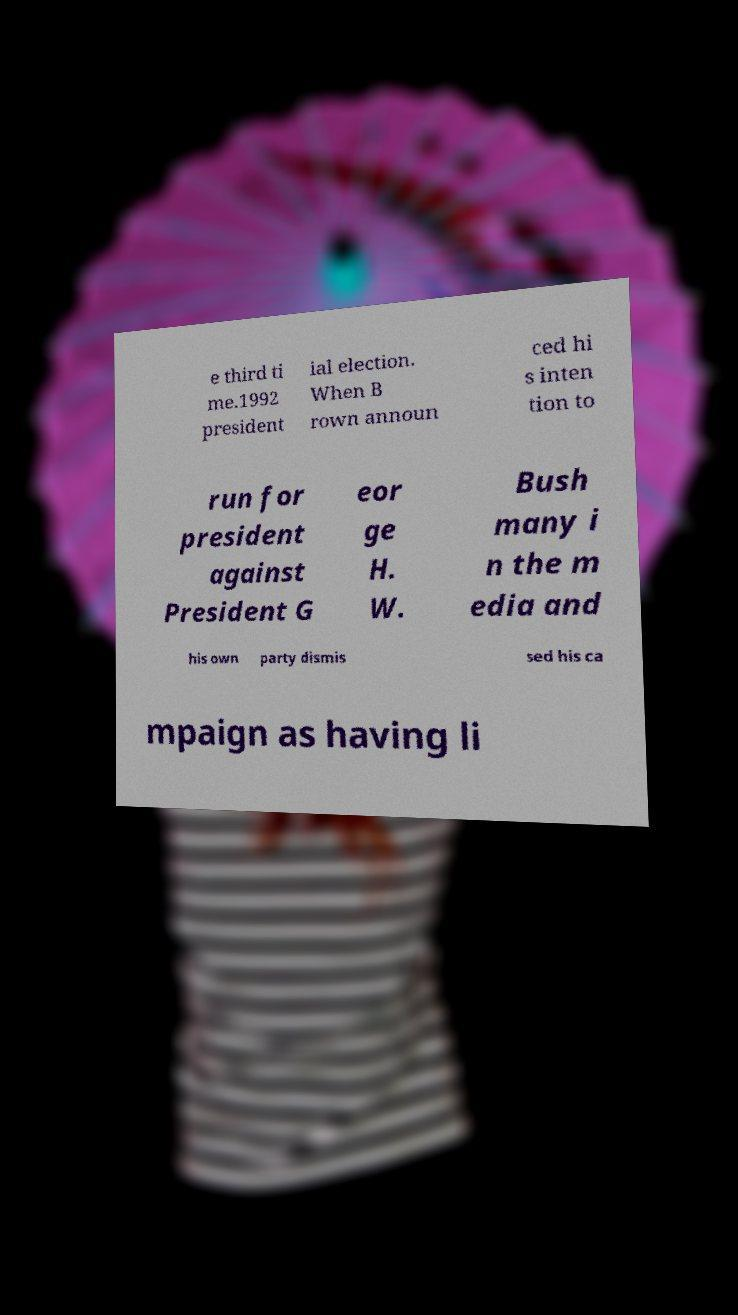Can you read and provide the text displayed in the image?This photo seems to have some interesting text. Can you extract and type it out for me? e third ti me.1992 president ial election. When B rown announ ced hi s inten tion to run for president against President G eor ge H. W. Bush many i n the m edia and his own party dismis sed his ca mpaign as having li 